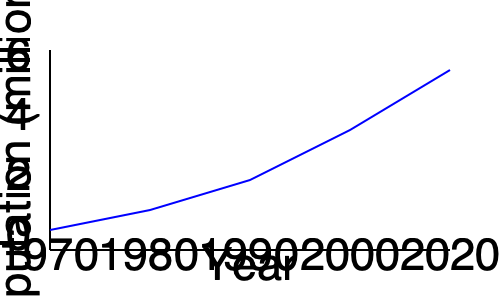The graph shows the population growth of Ho Chi Minh City over the past 50 years. Based on the trend shown, what was the approximate population of the city in 2020, and how does this compare to when you were growing up in the 1990s? To answer this question, let's analyze the graph step-by-step:

1. The x-axis represents years from 1970 to 2020, while the y-axis shows population in millions.

2. For the 2020 population:
   - The rightmost point on the graph corresponds to 2020.
   - This point aligns with approximately 6 million on the y-axis.

3. For the 1990s population:
   - The middle point on the x-axis represents 1990.
   - This point corresponds to about 3 million on the y-axis.

4. Comparing the two:
   - 2020 population: $\approx$ 6 million
   - 1990 population: $\approx$ 3 million
   - The population has roughly doubled over this 30-year period.

5. Calculate the growth:
   $\text{Growth} = \frac{\text{2020 population} - \text{1990 population}}{\text{1990 population}} \times 100\%$
   $= \frac{6 - 3}{3} \times 100\% = 100\%$

Thus, the population of Ho Chi Minh City in 2020 was about 6 million, which is approximately double what it was in the 1990s when you were growing up.
Answer: 6 million; doubled since the 1990s 